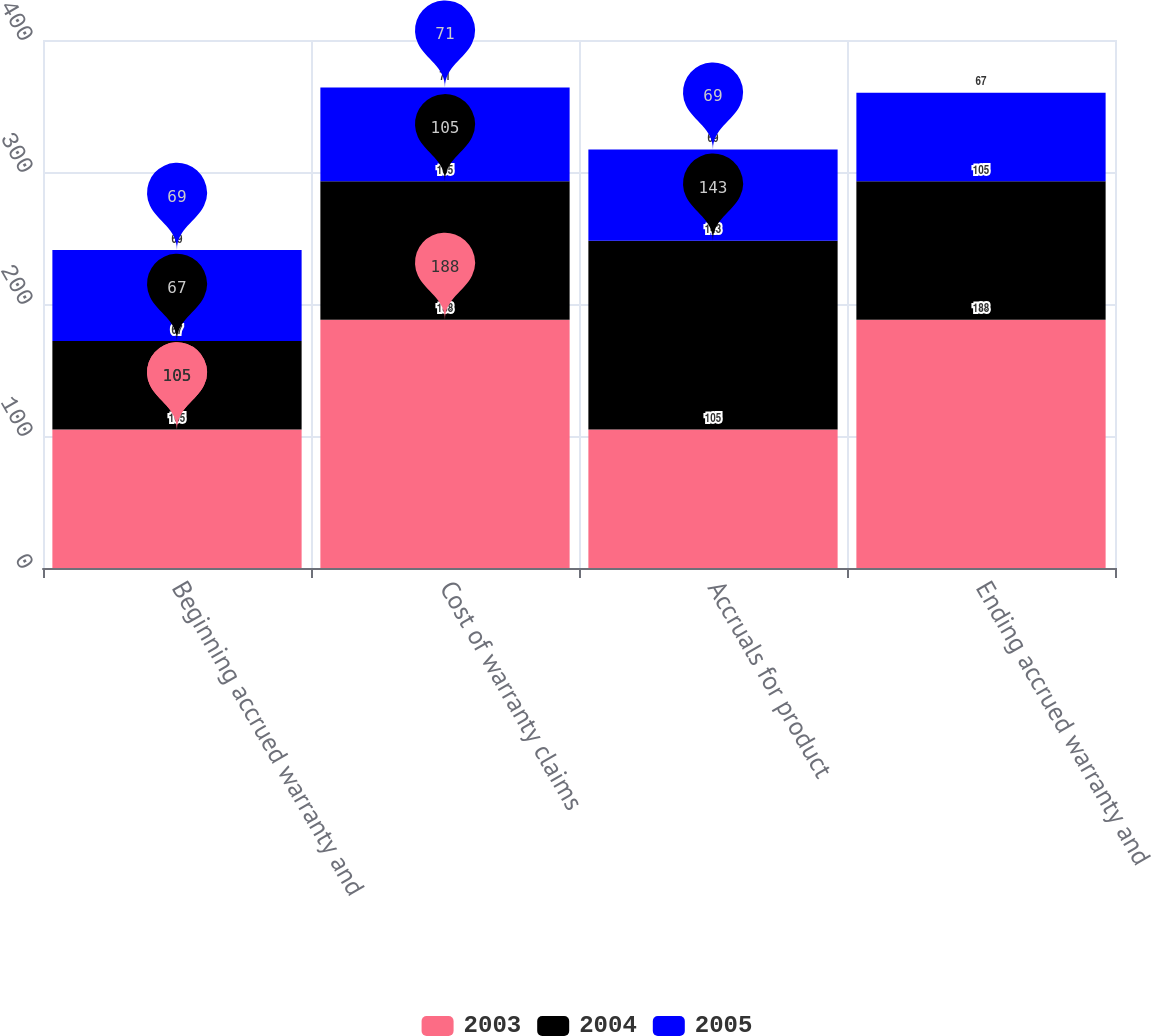<chart> <loc_0><loc_0><loc_500><loc_500><stacked_bar_chart><ecel><fcel>Beginning accrued warranty and<fcel>Cost of warranty claims<fcel>Accruals for product<fcel>Ending accrued warranty and<nl><fcel>2003<fcel>105<fcel>188<fcel>105<fcel>188<nl><fcel>2004<fcel>67<fcel>105<fcel>143<fcel>105<nl><fcel>2005<fcel>69<fcel>71<fcel>69<fcel>67<nl></chart> 